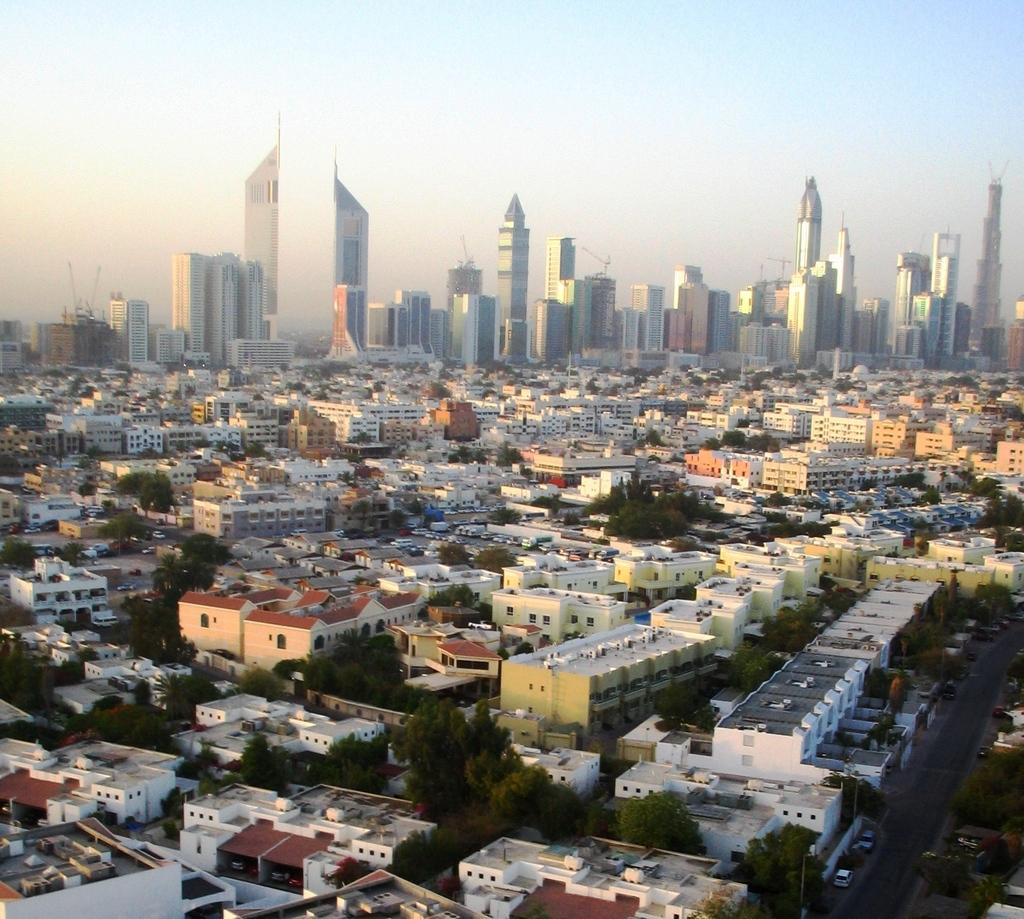What type of structures can be seen in the image? There are buildings in the image. What other natural elements are present in the image? There are trees in the image. Is there any man-made infrastructure visible in the image? Yes, there is a road in the image. What is visible at the top of the image? The sky is visible at the top of the image. Can you see a bear falling from a tree in the image? There is no bear or any falling object present in the image. What type of juice is being served in the image? There is no juice or any food or drink visible in the image. 